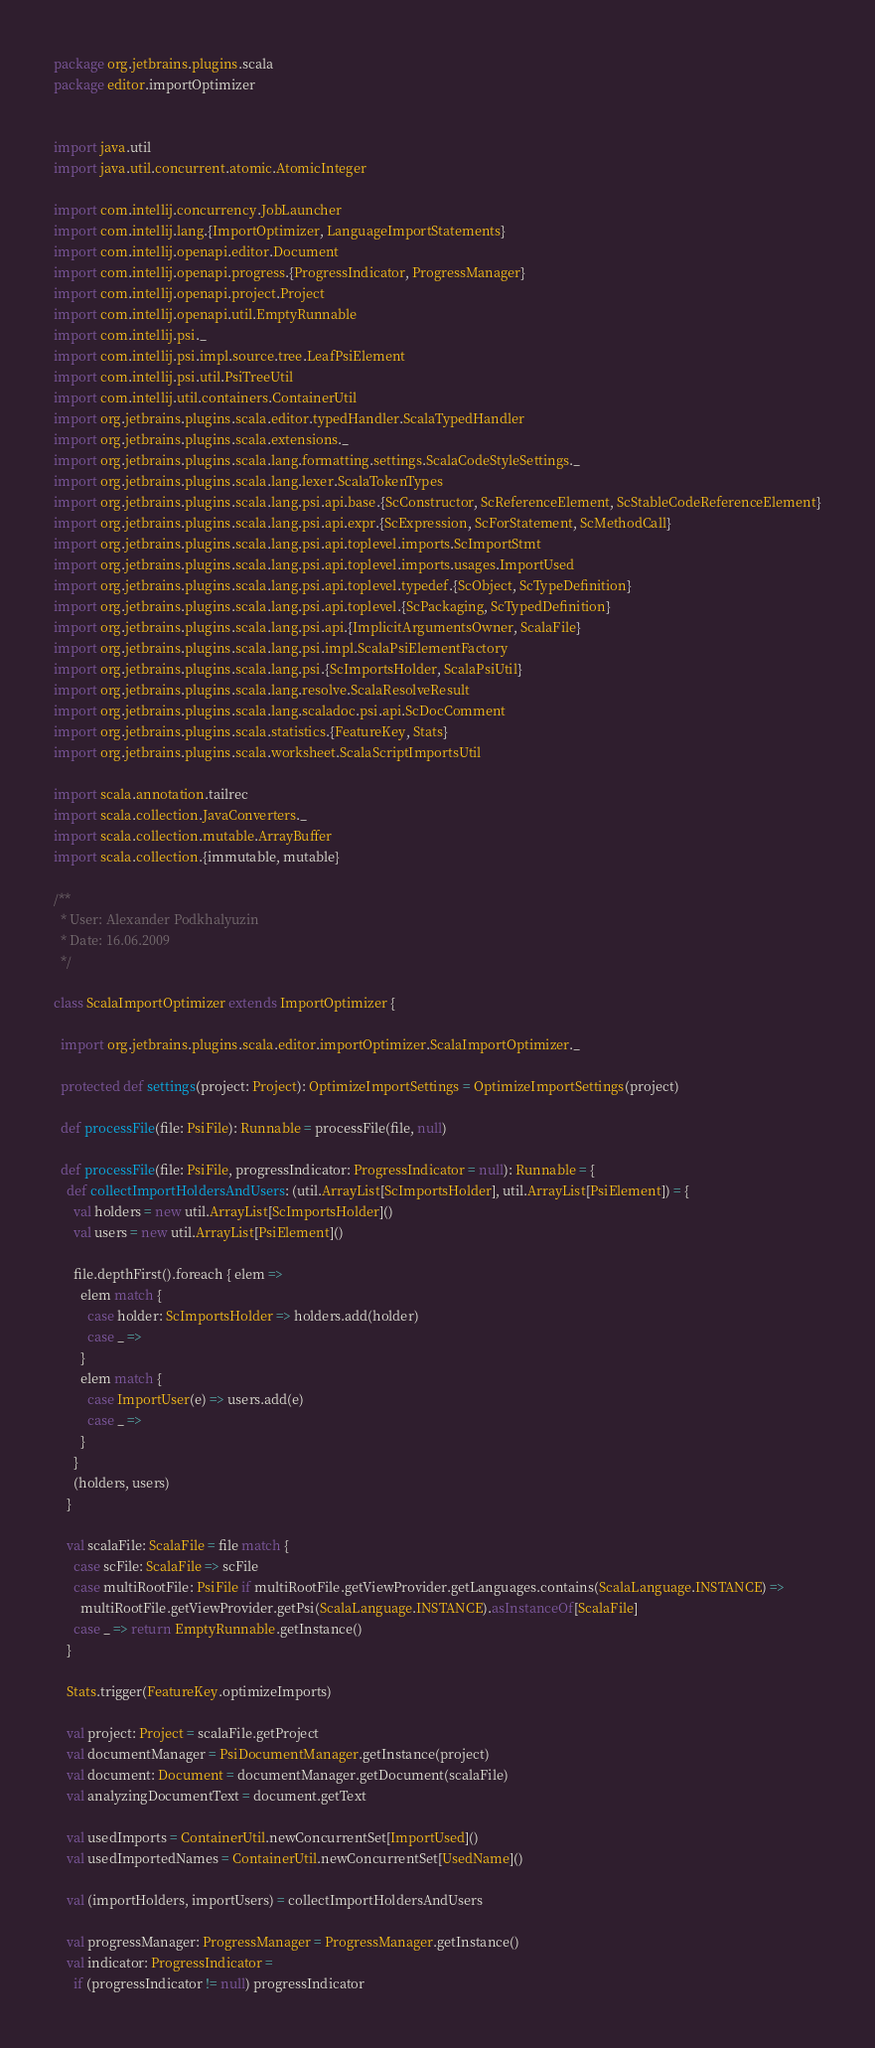<code> <loc_0><loc_0><loc_500><loc_500><_Scala_>package org.jetbrains.plugins.scala
package editor.importOptimizer


import java.util
import java.util.concurrent.atomic.AtomicInteger

import com.intellij.concurrency.JobLauncher
import com.intellij.lang.{ImportOptimizer, LanguageImportStatements}
import com.intellij.openapi.editor.Document
import com.intellij.openapi.progress.{ProgressIndicator, ProgressManager}
import com.intellij.openapi.project.Project
import com.intellij.openapi.util.EmptyRunnable
import com.intellij.psi._
import com.intellij.psi.impl.source.tree.LeafPsiElement
import com.intellij.psi.util.PsiTreeUtil
import com.intellij.util.containers.ContainerUtil
import org.jetbrains.plugins.scala.editor.typedHandler.ScalaTypedHandler
import org.jetbrains.plugins.scala.extensions._
import org.jetbrains.plugins.scala.lang.formatting.settings.ScalaCodeStyleSettings._
import org.jetbrains.plugins.scala.lang.lexer.ScalaTokenTypes
import org.jetbrains.plugins.scala.lang.psi.api.base.{ScConstructor, ScReferenceElement, ScStableCodeReferenceElement}
import org.jetbrains.plugins.scala.lang.psi.api.expr.{ScExpression, ScForStatement, ScMethodCall}
import org.jetbrains.plugins.scala.lang.psi.api.toplevel.imports.ScImportStmt
import org.jetbrains.plugins.scala.lang.psi.api.toplevel.imports.usages.ImportUsed
import org.jetbrains.plugins.scala.lang.psi.api.toplevel.typedef.{ScObject, ScTypeDefinition}
import org.jetbrains.plugins.scala.lang.psi.api.toplevel.{ScPackaging, ScTypedDefinition}
import org.jetbrains.plugins.scala.lang.psi.api.{ImplicitArgumentsOwner, ScalaFile}
import org.jetbrains.plugins.scala.lang.psi.impl.ScalaPsiElementFactory
import org.jetbrains.plugins.scala.lang.psi.{ScImportsHolder, ScalaPsiUtil}
import org.jetbrains.plugins.scala.lang.resolve.ScalaResolveResult
import org.jetbrains.plugins.scala.lang.scaladoc.psi.api.ScDocComment
import org.jetbrains.plugins.scala.statistics.{FeatureKey, Stats}
import org.jetbrains.plugins.scala.worksheet.ScalaScriptImportsUtil

import scala.annotation.tailrec
import scala.collection.JavaConverters._
import scala.collection.mutable.ArrayBuffer
import scala.collection.{immutable, mutable}

/**
  * User: Alexander Podkhalyuzin
  * Date: 16.06.2009
  */

class ScalaImportOptimizer extends ImportOptimizer {

  import org.jetbrains.plugins.scala.editor.importOptimizer.ScalaImportOptimizer._

  protected def settings(project: Project): OptimizeImportSettings = OptimizeImportSettings(project)

  def processFile(file: PsiFile): Runnable = processFile(file, null)

  def processFile(file: PsiFile, progressIndicator: ProgressIndicator = null): Runnable = {
    def collectImportHoldersAndUsers: (util.ArrayList[ScImportsHolder], util.ArrayList[PsiElement]) = {
      val holders = new util.ArrayList[ScImportsHolder]()
      val users = new util.ArrayList[PsiElement]()

      file.depthFirst().foreach { elem =>
        elem match {
          case holder: ScImportsHolder => holders.add(holder)
          case _ =>
        }
        elem match {
          case ImportUser(e) => users.add(e)
          case _ =>
        }
      }
      (holders, users)
    }

    val scalaFile: ScalaFile = file match {
      case scFile: ScalaFile => scFile
      case multiRootFile: PsiFile if multiRootFile.getViewProvider.getLanguages.contains(ScalaLanguage.INSTANCE) =>
        multiRootFile.getViewProvider.getPsi(ScalaLanguage.INSTANCE).asInstanceOf[ScalaFile]
      case _ => return EmptyRunnable.getInstance()
    }

    Stats.trigger(FeatureKey.optimizeImports)

    val project: Project = scalaFile.getProject
    val documentManager = PsiDocumentManager.getInstance(project)
    val document: Document = documentManager.getDocument(scalaFile)
    val analyzingDocumentText = document.getText

    val usedImports = ContainerUtil.newConcurrentSet[ImportUsed]()
    val usedImportedNames = ContainerUtil.newConcurrentSet[UsedName]()

    val (importHolders, importUsers) = collectImportHoldersAndUsers

    val progressManager: ProgressManager = ProgressManager.getInstance()
    val indicator: ProgressIndicator =
      if (progressIndicator != null) progressIndicator</code> 